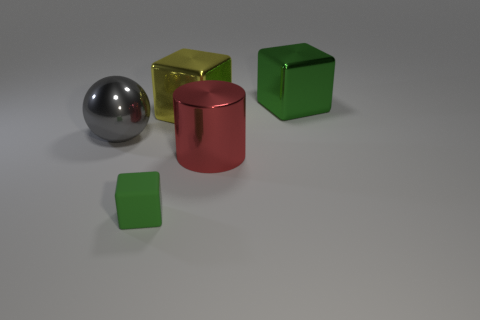Add 4 brown rubber blocks. How many objects exist? 9 Subtract all cylinders. How many objects are left? 4 Add 1 red objects. How many red objects are left? 2 Add 4 tiny red metallic cylinders. How many tiny red metallic cylinders exist? 4 Subtract 1 gray balls. How many objects are left? 4 Subtract all metal blocks. Subtract all big purple metallic blocks. How many objects are left? 3 